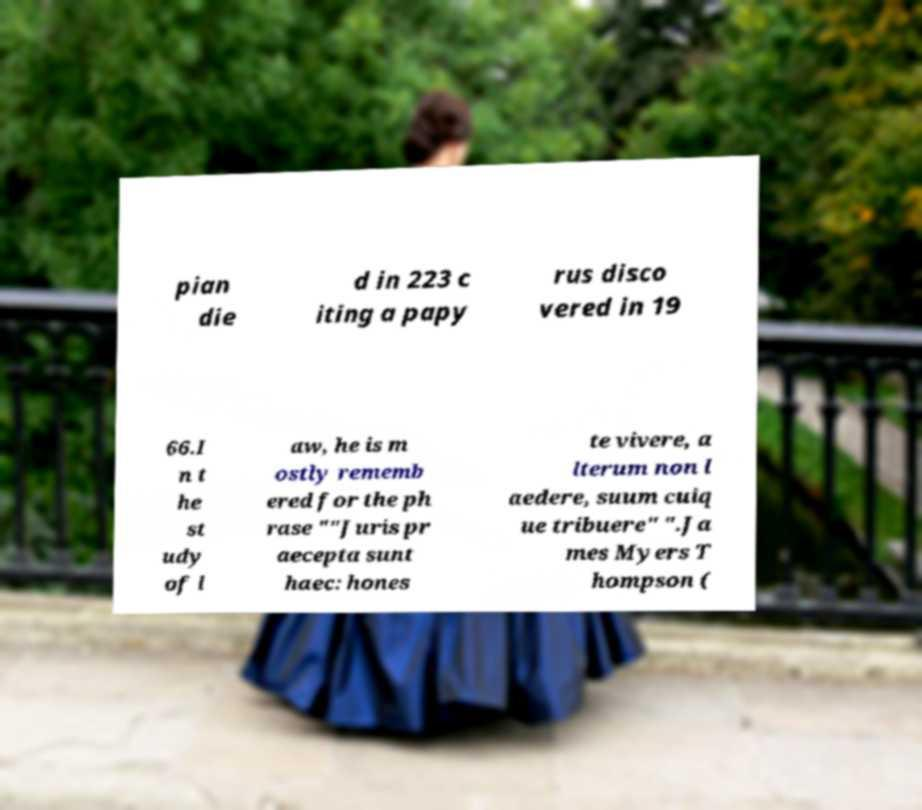Could you extract and type out the text from this image? pian die d in 223 c iting a papy rus disco vered in 19 66.I n t he st udy of l aw, he is m ostly rememb ered for the ph rase ""Juris pr aecepta sunt haec: hones te vivere, a lterum non l aedere, suum cuiq ue tribuere" ".Ja mes Myers T hompson ( 